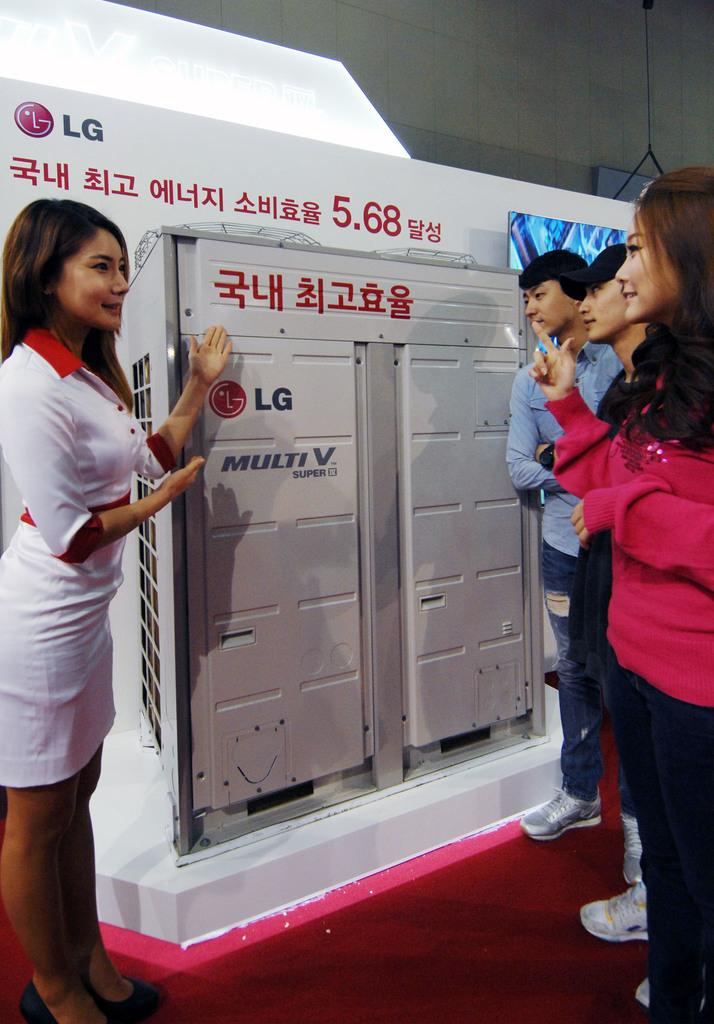<image>
Summarize the visual content of the image. A woman standing next to a display of an LG product 